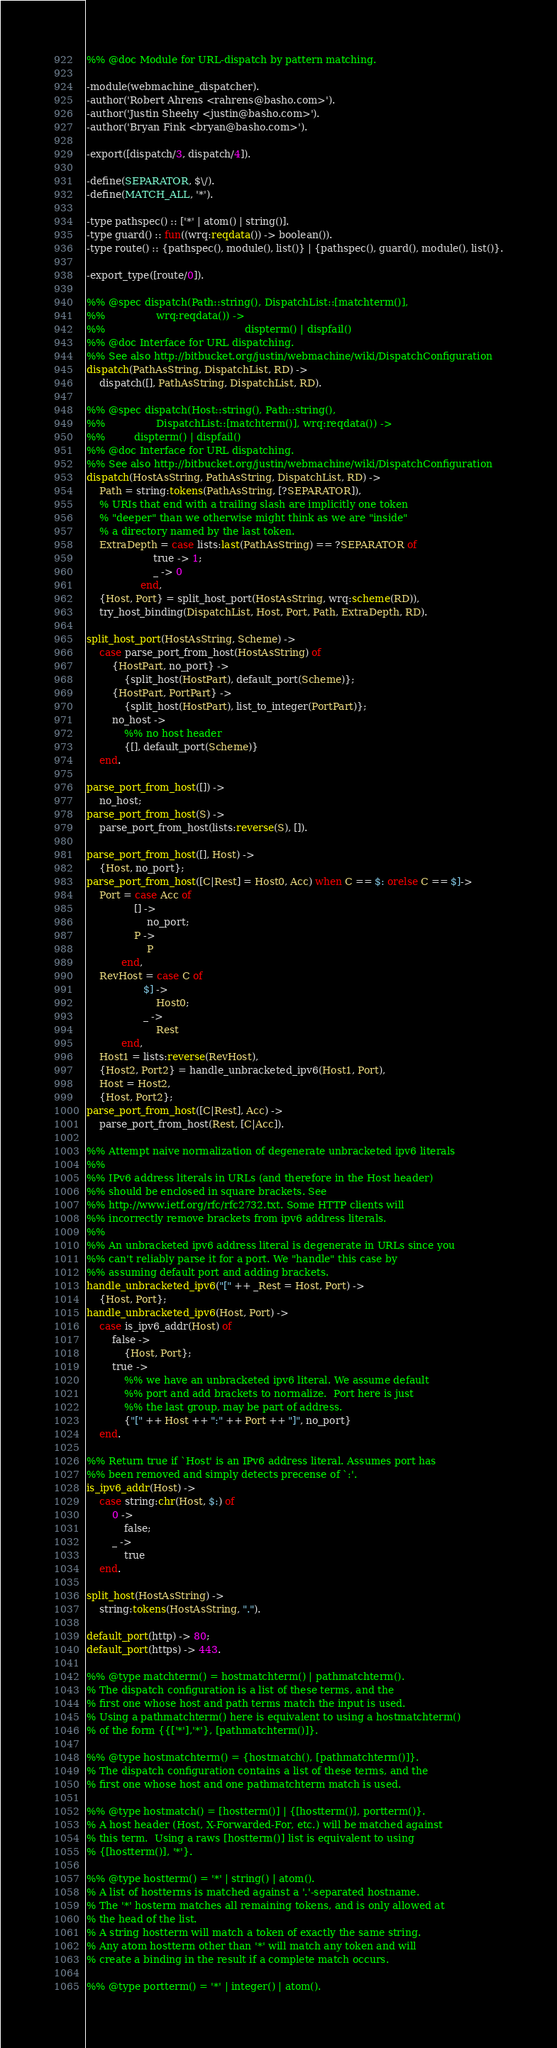<code> <loc_0><loc_0><loc_500><loc_500><_Erlang_>%% @doc Module for URL-dispatch by pattern matching.

-module(webmachine_dispatcher).
-author('Robert Ahrens <rahrens@basho.com>').
-author('Justin Sheehy <justin@basho.com>').
-author('Bryan Fink <bryan@basho.com>').

-export([dispatch/3, dispatch/4]).

-define(SEPARATOR, $\/).
-define(MATCH_ALL, '*').

-type pathspec() :: ['*' | atom() | string()].
-type guard() :: fun((wrq:reqdata()) -> boolean()).
-type route() :: {pathspec(), module(), list()} | {pathspec(), guard(), module(), list()}.

-export_type([route/0]).

%% @spec dispatch(Path::string(), DispatchList::[matchterm()],
%%                wrq:reqdata()) ->
%%                                            dispterm() | dispfail()
%% @doc Interface for URL dispatching.
%% See also http://bitbucket.org/justin/webmachine/wiki/DispatchConfiguration
dispatch(PathAsString, DispatchList, RD) ->
    dispatch([], PathAsString, DispatchList, RD).

%% @spec dispatch(Host::string(), Path::string(),
%%                DispatchList::[matchterm()], wrq:reqdata()) ->
%%         dispterm() | dispfail()
%% @doc Interface for URL dispatching.
%% See also http://bitbucket.org/justin/webmachine/wiki/DispatchConfiguration
dispatch(HostAsString, PathAsString, DispatchList, RD) ->
    Path = string:tokens(PathAsString, [?SEPARATOR]),
    % URIs that end with a trailing slash are implicitly one token
    % "deeper" than we otherwise might think as we are "inside"
    % a directory named by the last token.
    ExtraDepth = case lists:last(PathAsString) == ?SEPARATOR of
                     true -> 1;
                     _ -> 0
                 end,
    {Host, Port} = split_host_port(HostAsString, wrq:scheme(RD)),
    try_host_binding(DispatchList, Host, Port, Path, ExtraDepth, RD).

split_host_port(HostAsString, Scheme) ->
    case parse_port_from_host(HostAsString) of
        {HostPart, no_port} ->
            {split_host(HostPart), default_port(Scheme)};
        {HostPart, PortPart} ->
            {split_host(HostPart), list_to_integer(PortPart)};
        no_host ->
            %% no host header
            {[], default_port(Scheme)}
    end.

parse_port_from_host([]) ->
    no_host;
parse_port_from_host(S) ->
    parse_port_from_host(lists:reverse(S), []).

parse_port_from_host([], Host) ->
    {Host, no_port};
parse_port_from_host([C|Rest] = Host0, Acc) when C == $: orelse C == $]->
    Port = case Acc of
               [] ->
                   no_port;
               P ->
                   P
           end,
    RevHost = case C of
                  $] ->
                      Host0;
                  _ ->
                      Rest
           end,
    Host1 = lists:reverse(RevHost),
    {Host2, Port2} = handle_unbracketed_ipv6(Host1, Port),
    Host = Host2,
    {Host, Port2};
parse_port_from_host([C|Rest], Acc) ->
    parse_port_from_host(Rest, [C|Acc]).

%% Attempt naive normalization of degenerate unbracketed ipv6 literals
%%
%% IPv6 address literals in URLs (and therefore in the Host header)
%% should be enclosed in square brackets. See
%% http://www.ietf.org/rfc/rfc2732.txt. Some HTTP clients will
%% incorrectly remove brackets from ipv6 address literals.
%%
%% An unbracketed ipv6 address literal is degenerate in URLs since you
%% can't reliably parse it for a port. We "handle" this case by
%% assuming default port and adding brackets.
handle_unbracketed_ipv6("[" ++ _Rest = Host, Port) ->
    {Host, Port};
handle_unbracketed_ipv6(Host, Port) ->
    case is_ipv6_addr(Host) of
        false ->
            {Host, Port};
        true ->
            %% we have an unbracketed ipv6 literal. We assume default
            %% port and add brackets to normalize.  Port here is just
            %% the last group, may be part of address.
            {"[" ++ Host ++ ":" ++ Port ++ "]", no_port}
    end.

%% Return true if `Host' is an IPv6 address literal. Assumes port has
%% been removed and simply detects precense of `:'.
is_ipv6_addr(Host) ->
    case string:chr(Host, $:) of
        0 ->
            false;
        _ ->
            true
    end.

split_host(HostAsString) ->
    string:tokens(HostAsString, ".").

default_port(http) -> 80;
default_port(https) -> 443.

%% @type matchterm() = hostmatchterm() | pathmatchterm().
% The dispatch configuration is a list of these terms, and the
% first one whose host and path terms match the input is used.
% Using a pathmatchterm() here is equivalent to using a hostmatchterm()
% of the form {{['*'],'*'}, [pathmatchterm()]}.

%% @type hostmatchterm() = {hostmatch(), [pathmatchterm()]}.
% The dispatch configuration contains a list of these terms, and the
% first one whose host and one pathmatchterm match is used.

%% @type hostmatch() = [hostterm()] | {[hostterm()], portterm()}.
% A host header (Host, X-Forwarded-For, etc.) will be matched against
% this term.  Using a raws [hostterm()] list is equivalent to using
% {[hostterm()], '*'}.

%% @type hostterm() = '*' | string() | atom().
% A list of hostterms is matched against a '.'-separated hostname.
% The '*' hosterm matches all remaining tokens, and is only allowed at
% the head of the list.
% A string hostterm will match a token of exactly the same string.
% Any atom hostterm other than '*' will match any token and will
% create a binding in the result if a complete match occurs.

%% @type portterm() = '*' | integer() | atom().</code> 